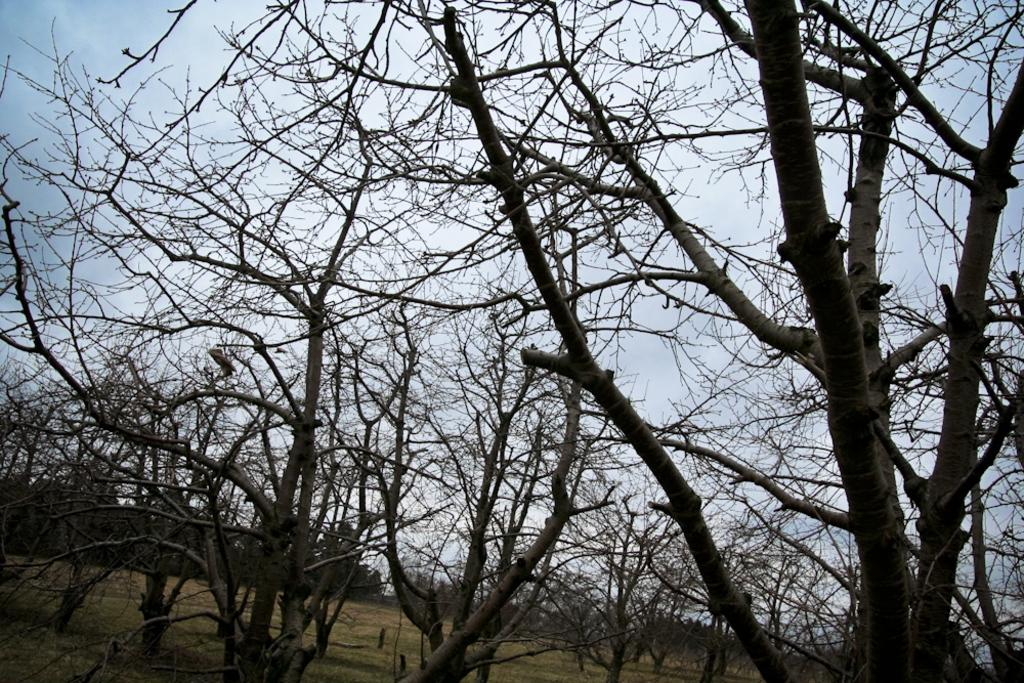What type of vegetation can be seen in the image? There are many dry trees in the image. Where are the trees located? The trees are on the land. What is visible above the trees in the image? The sky is visible above the trees. What type of sheet is covering the trees in the image? There is no sheet present in the image; the trees are dry and exposed. 